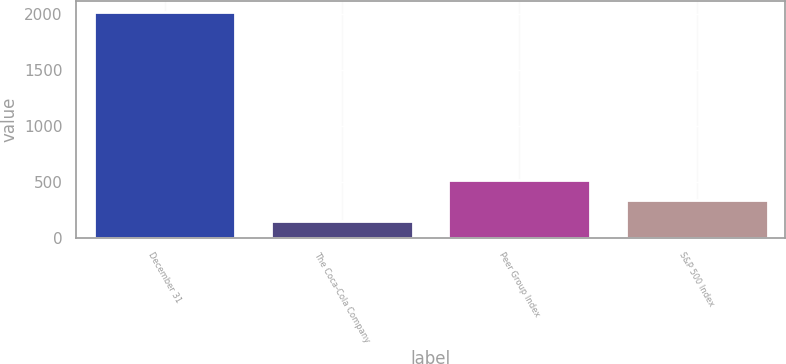Convert chart. <chart><loc_0><loc_0><loc_500><loc_500><bar_chart><fcel>December 31<fcel>The Coca-Cola Company<fcel>Peer Group Index<fcel>S&P 500 Index<nl><fcel>2014<fcel>144<fcel>518<fcel>331<nl></chart> 